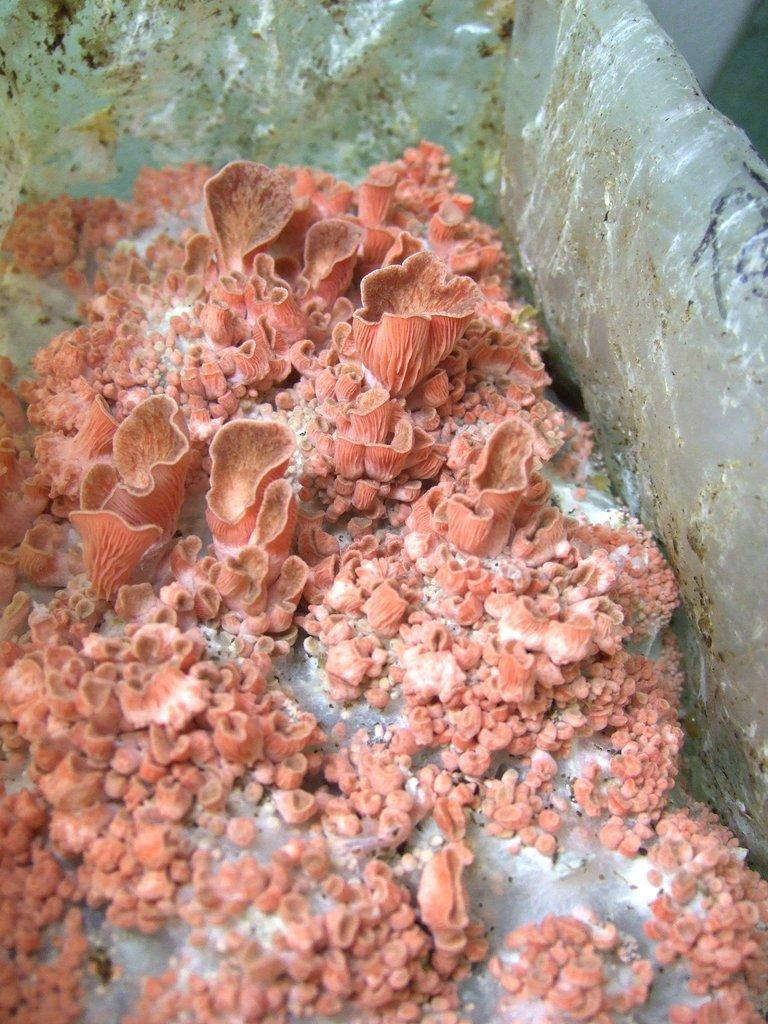Can you describe this image briefly? This image consists of a sea plant. It looks like it is kept in the ice. 